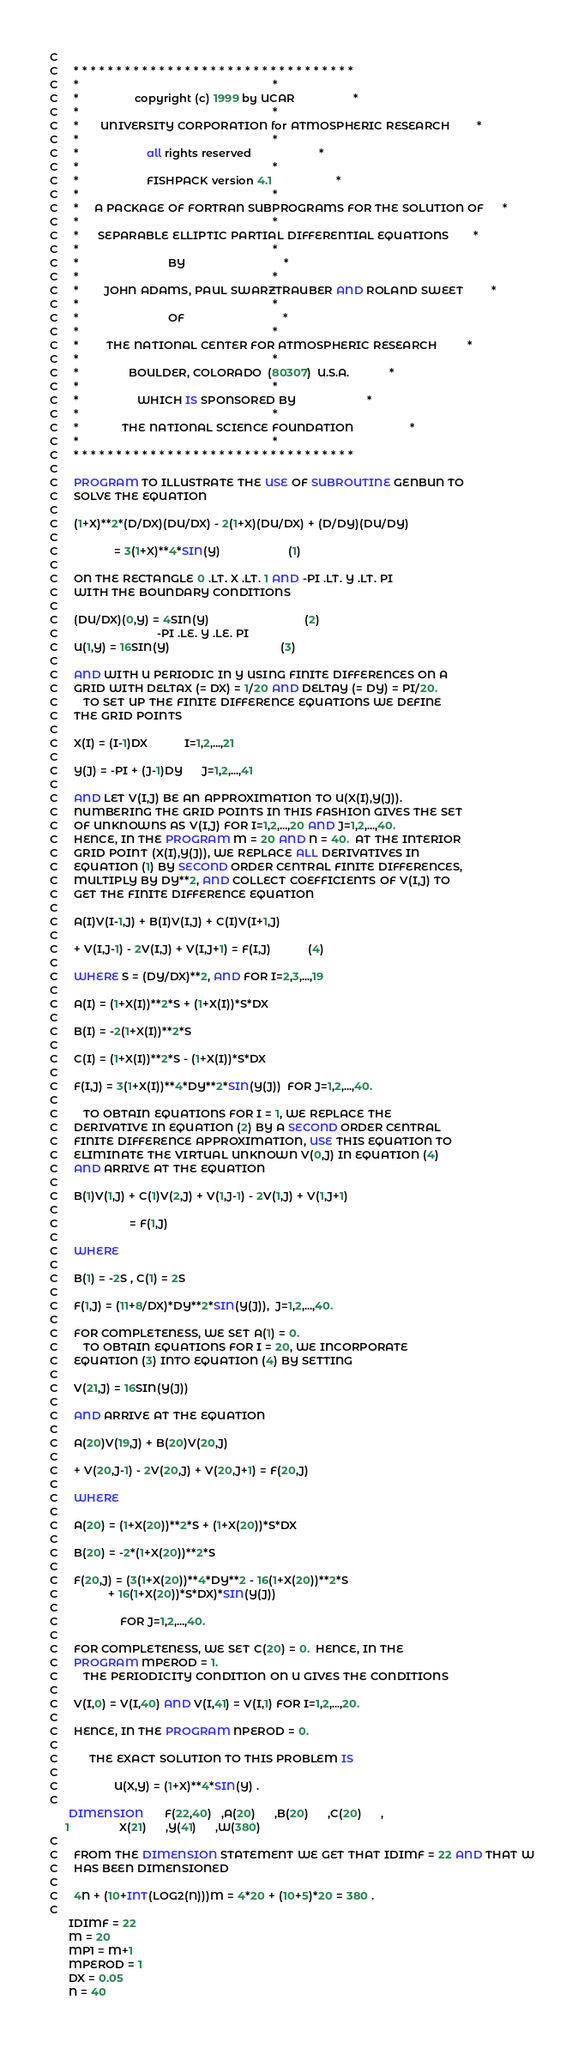<code> <loc_0><loc_0><loc_500><loc_500><_FORTRAN_>C
C     * * * * * * * * * * * * * * * * * * * * * * * * * * * * * * * * *
C     *                                                               *
C     *                  copyright (c) 1999 by UCAR                   *
C     *                                                               *
C     *       UNIVERSITY CORPORATION for ATMOSPHERIC RESEARCH         *
C     *                                                               *
C     *                      all rights reserved                      *
C     *                                                               *
C     *                      FISHPACK version 4.1                     *
C     *                                                               *
C     *     A PACKAGE OF FORTRAN SUBPROGRAMS FOR THE SOLUTION OF      *
C     *                                                               *
C     *      SEPARABLE ELLIPTIC PARTIAL DIFFERENTIAL EQUATIONS        *
C     *                                                               *
C     *                             BY                                *
C     *                                                               *
C     *        JOHN ADAMS, PAUL SWARZTRAUBER AND ROLAND SWEET         *
C     *                                                               *
C     *                             OF                                *
C     *                                                               *
C     *         THE NATIONAL CENTER FOR ATMOSPHERIC RESEARCH          *
C     *                                                               *
C     *                BOULDER, COLORADO  (80307)  U.S.A.             *
C     *                                                               *
C     *                   WHICH IS SPONSORED BY                       *
C     *                                                               *
C     *              THE NATIONAL SCIENCE FOUNDATION                  *
C     *                                                               *
C     * * * * * * * * * * * * * * * * * * * * * * * * * * * * * * * * *
C
C     PROGRAM TO ILLUSTRATE THE USE OF SUBROUTINE GENBUN TO
C     SOLVE THE EQUATION
C
C     (1+X)**2*(D/DX)(DU/DX) - 2(1+X)(DU/DX) + (D/DY)(DU/DY)
C
C                  = 3(1+X)**4*SIN(Y)                      (1)
C
C     ON THE RECTANGLE 0 .LT. X .LT. 1 AND -PI .LT. Y .LT. PI
C     WITH THE BOUNDARY CONDITIONS
C
C     (DU/DX)(0,Y) = 4SIN(Y)                               (2)
C                                -PI .LE. Y .LE. PI
C     U(1,Y) = 16SIN(Y)                                    (3)
C
C     AND WITH U PERIODIC IN Y USING FINITE DIFFERENCES ON A
C     GRID WITH DELTAX (= DX) = 1/20 AND DELTAY (= DY) = PI/20.
C        TO SET UP THE FINITE DIFFERENCE EQUATIONS WE DEFINE
C     THE GRID POINTS
C
C     X(I) = (I-1)DX            I=1,2,...,21
C
C     Y(J) = -PI + (J-1)DY      J=1,2,...,41
C
C     AND LET V(I,J) BE AN APPROXIMATION TO U(X(I),Y(J)).
C     NUMBERING THE GRID POINTS IN THIS FASHION GIVES THE SET
C     OF UNKNOWNS AS V(I,J) FOR I=1,2,...,20 AND J=1,2,...,40.
C     HENCE, IN THE PROGRAM M = 20 AND N = 40.  AT THE INTERIOR
C     GRID POINT (X(I),Y(J)), WE REPLACE ALL DERIVATIVES IN
C     EQUATION (1) BY SECOND ORDER CENTRAL FINITE DIFFERENCES,
C     MULTIPLY BY DY**2, AND COLLECT COEFFICIENTS OF V(I,J) TO
C     GET THE FINITE DIFFERENCE EQUATION
C
C     A(I)V(I-1,J) + B(I)V(I,J) + C(I)V(I+1,J)
C
C     + V(I,J-1) - 2V(I,J) + V(I,J+1) = F(I,J)            (4)
C
C     WHERE S = (DY/DX)**2, AND FOR I=2,3,...,19
C
C     A(I) = (1+X(I))**2*S + (1+X(I))*S*DX
C
C     B(I) = -2(1+X(I))**2*S
C
C     C(I) = (1+X(I))**2*S - (1+X(I))*S*DX
C
C     F(I,J) = 3(1+X(I))**4*DY**2*SIN(Y(J))  FOR J=1,2,...,40.
C
C        TO OBTAIN EQUATIONS FOR I = 1, WE REPLACE THE
C     DERIVATIVE IN EQUATION (2) BY A SECOND ORDER CENTRAL
C     FINITE DIFFERENCE APPROXIMATION, USE THIS EQUATION TO
C     ELIMINATE THE VIRTUAL UNKNOWN V(0,J) IN EQUATION (4)
C     AND ARRIVE AT THE EQUATION
C
C     B(1)V(1,J) + C(1)V(2,J) + V(1,J-1) - 2V(1,J) + V(1,J+1)
C
C                       = F(1,J)
C
C     WHERE
C
C     B(1) = -2S , C(1) = 2S
C
C     F(1,J) = (11+8/DX)*DY**2*SIN(Y(J)),  J=1,2,...,40.
C
C     FOR COMPLETENESS, WE SET A(1) = 0.
C        TO OBTAIN EQUATIONS FOR I = 20, WE INCORPORATE
C     EQUATION (3) INTO EQUATION (4) BY SETTING
C
C     V(21,J) = 16SIN(Y(J))
C
C     AND ARRIVE AT THE EQUATION
C
C     A(20)V(19,J) + B(20)V(20,J)
C
C     + V(20,J-1) - 2V(20,J) + V(20,J+1) = F(20,J)
C
C     WHERE
C
C     A(20) = (1+X(20))**2*S + (1+X(20))*S*DX
C
C     B(20) = -2*(1+X(20))**2*S
C
C     F(20,J) = (3(1+X(20))**4*DY**2 - 16(1+X(20))**2*S
C                + 16(1+X(20))*S*DX)*SIN(Y(J))
C
C                    FOR J=1,2,...,40.
C
C     FOR COMPLETENESS, WE SET C(20) = 0.  HENCE, IN THE
C     PROGRAM MPEROD = 1.
C        THE PERIODICITY CONDITION ON U GIVES THE CONDITIONS
C
C     V(I,0) = V(I,40) AND V(I,41) = V(I,1) FOR I=1,2,...,20.
C
C     HENCE, IN THE PROGRAM NPEROD = 0.
C
C          THE EXACT SOLUTION TO THIS PROBLEM IS
C
C                  U(X,Y) = (1+X)**4*SIN(Y) .
C
      DIMENSION       F(22,40)   ,A(20)      ,B(20)      ,C(20)      ,
     1                X(21)      ,Y(41)      ,W(380)
C
C     FROM THE DIMENSION STATEMENT WE GET THAT IDIMF = 22 AND THAT W
C     HAS BEEN DIMENSIONED
C
C     4N + (10+INT(LOG2(N)))M = 4*20 + (10+5)*20 = 380 .
C
      IDIMF = 22
      M = 20
      MP1 = M+1
      MPEROD = 1
      DX = 0.05
      N = 40</code> 